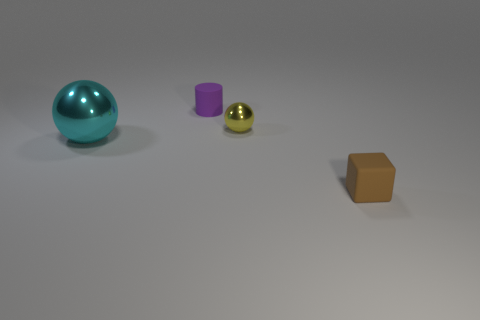How does the orange box compare in size to the other objects? The orange box is the largest in terms of height and length, dwarfing the purple cylinder, teal sphere, and the small golden-yellow sphere. 